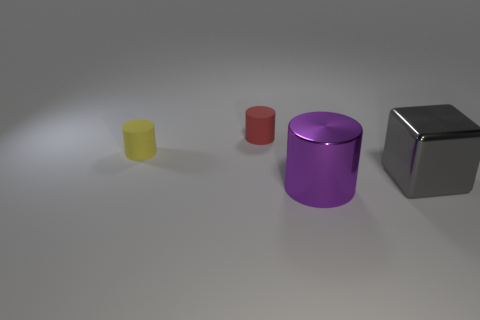Is there a specific art style or movement that this image could be associated with? The image could be associated with minimalism, a movement characterized by simple forms and limited color palettes, where the focus is on the essential qualities of the objects and the space they occupy. 